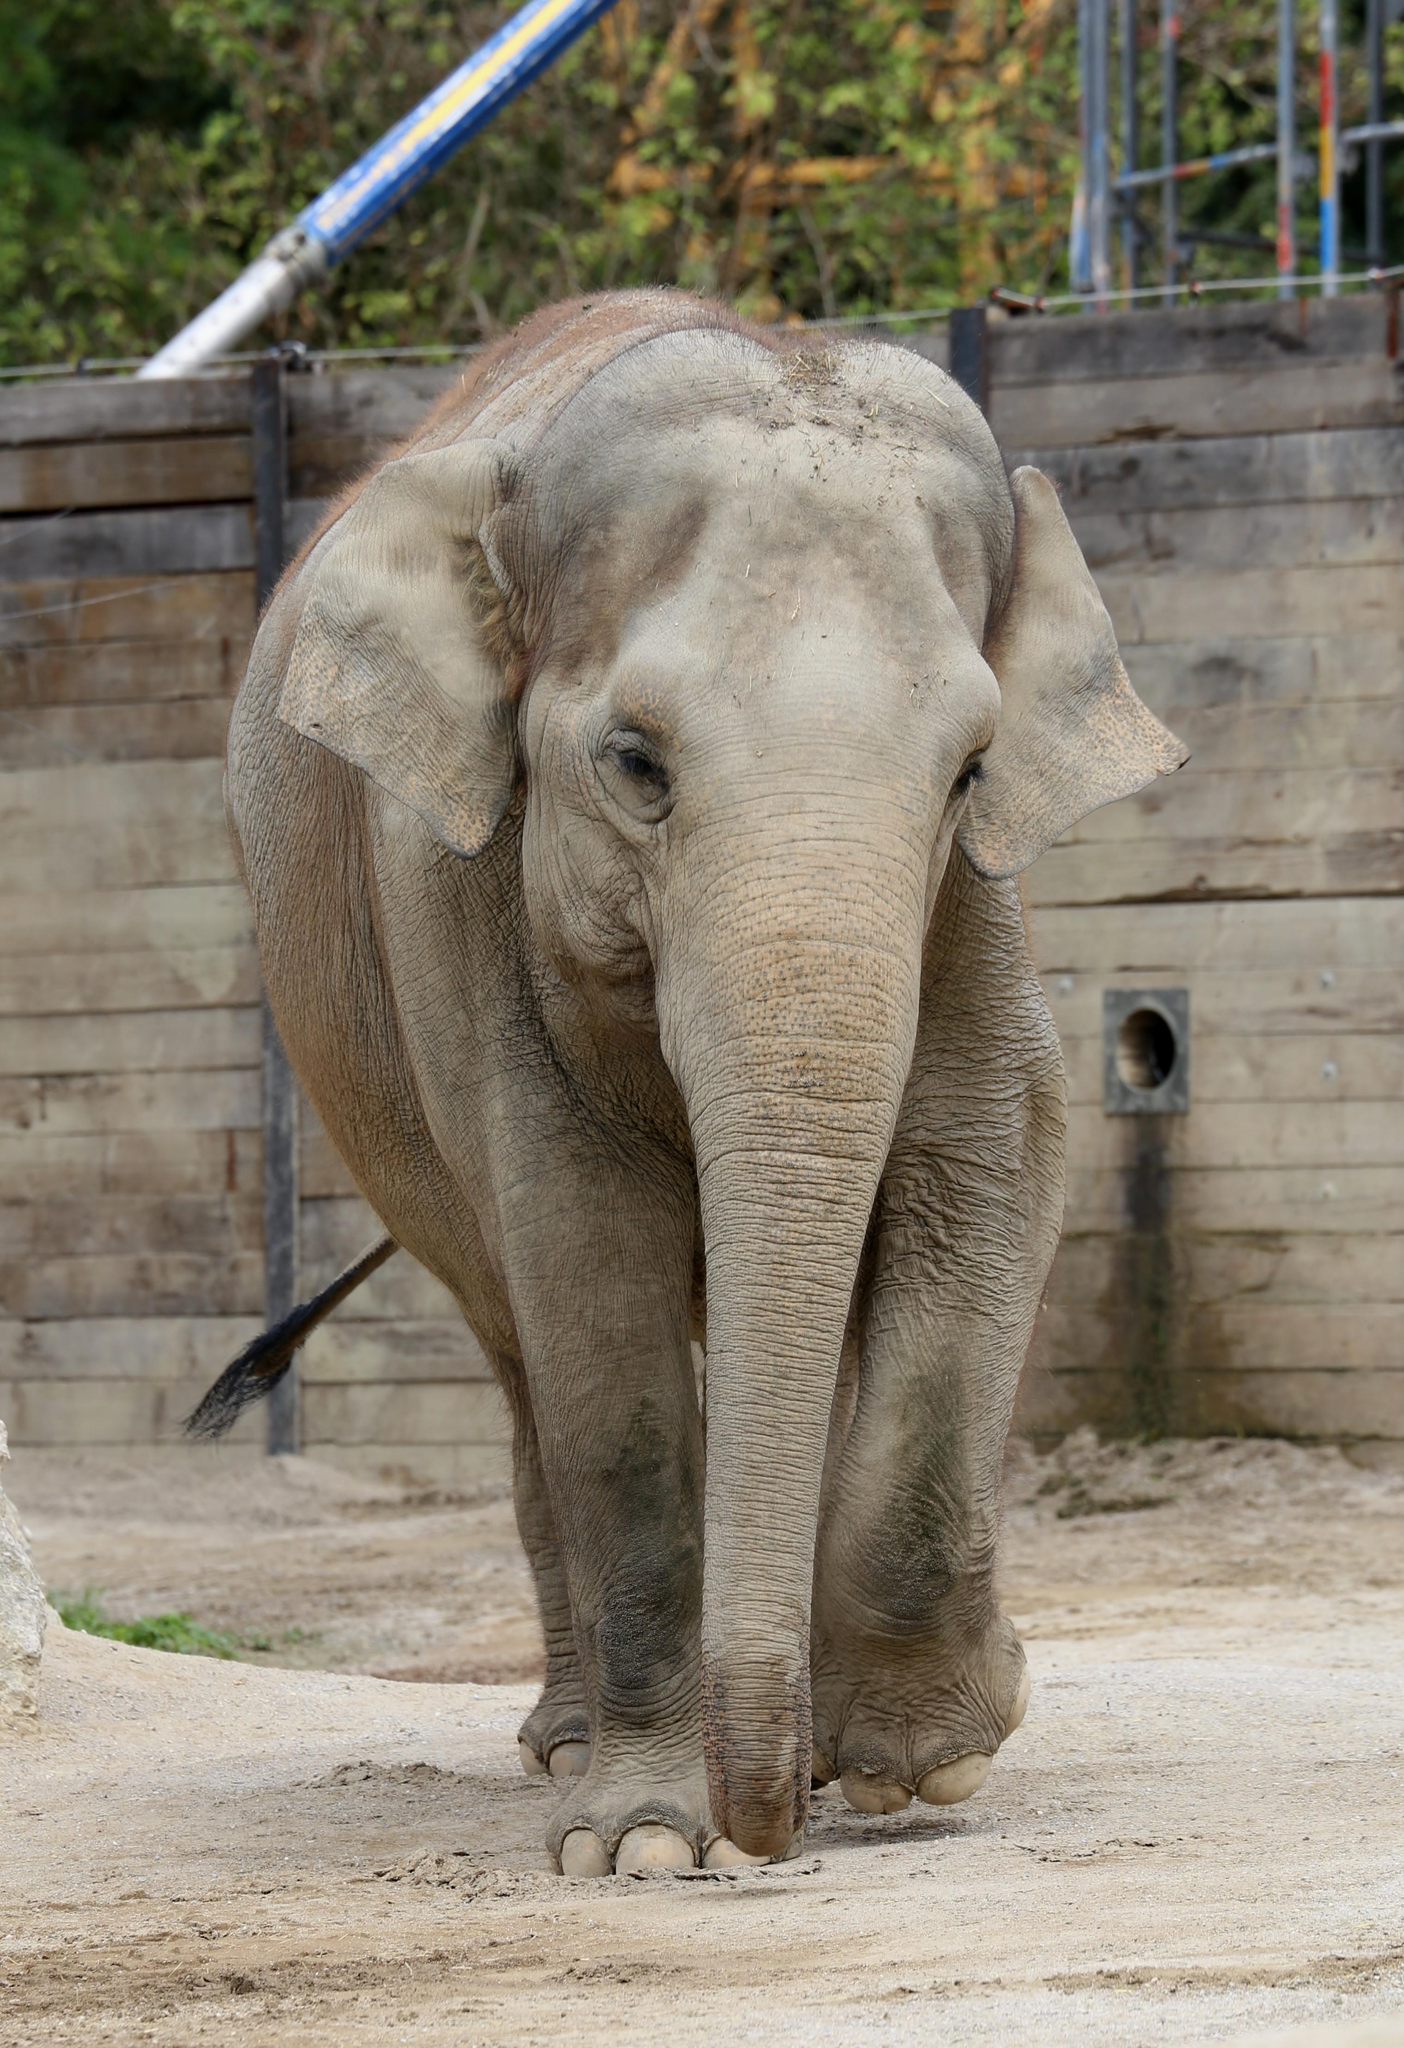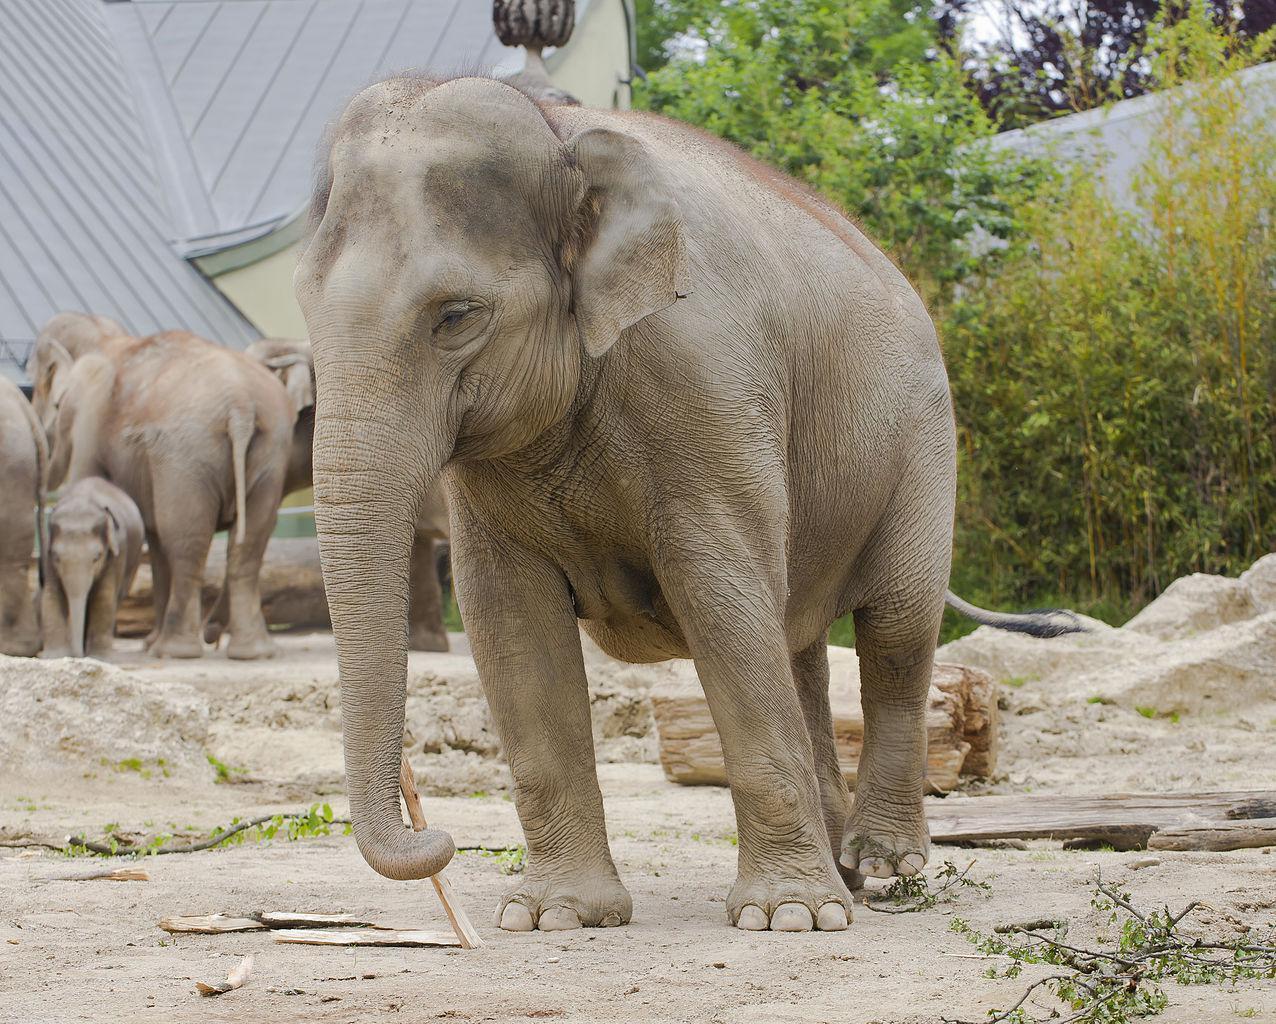The first image is the image on the left, the second image is the image on the right. Given the left and right images, does the statement "An image shows one elephant standing on a surface surrounded by a curved raised edge." hold true? Answer yes or no. No. The first image is the image on the left, the second image is the image on the right. Examine the images to the left and right. Is the description "The elephant in the right image is facing towards the right." accurate? Answer yes or no. No. 